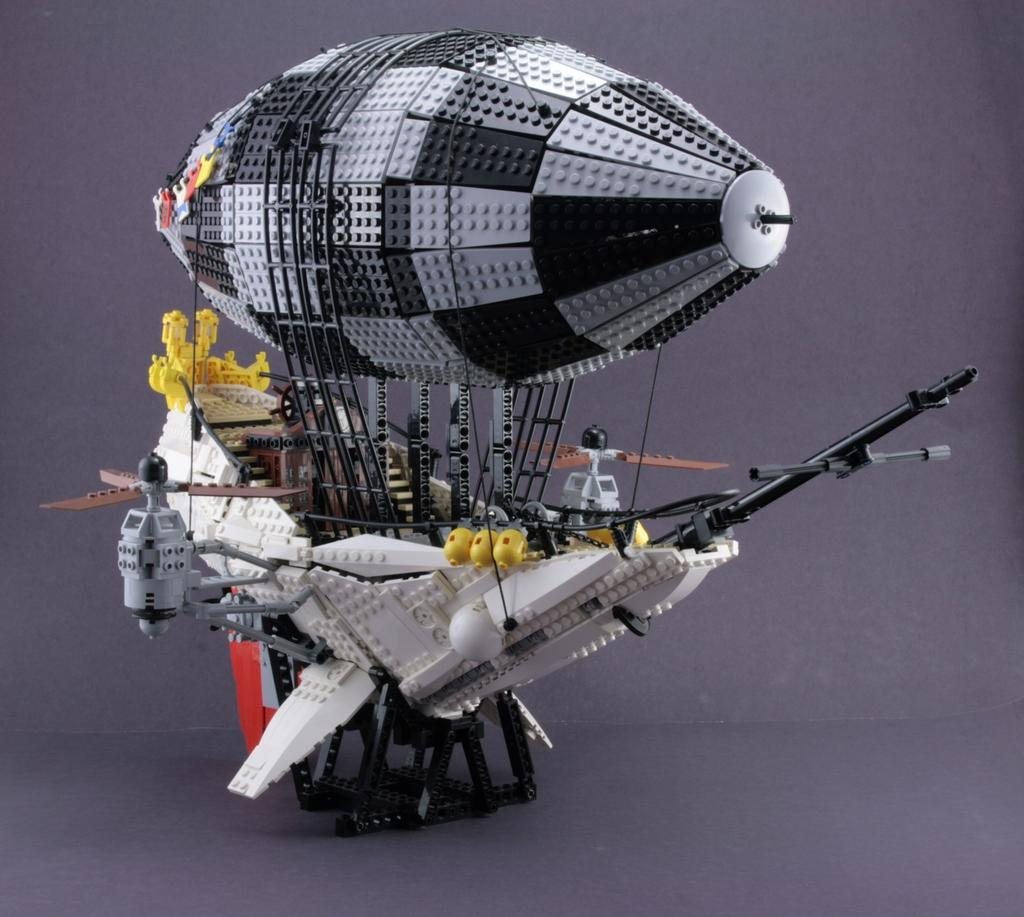What is the color of the surface in the image? The surface in the image is violet in color. What object can be seen on the surface? There is a Lego toy on the surface. Can you describe the colors of the Lego toy? The Lego toy has white, grey, black, red, brown, and yellow colors. Where is the pot located in the image? There is no pot present in the image. Can you describe the behavior of the fly in the image? There is no fly present in the image. 